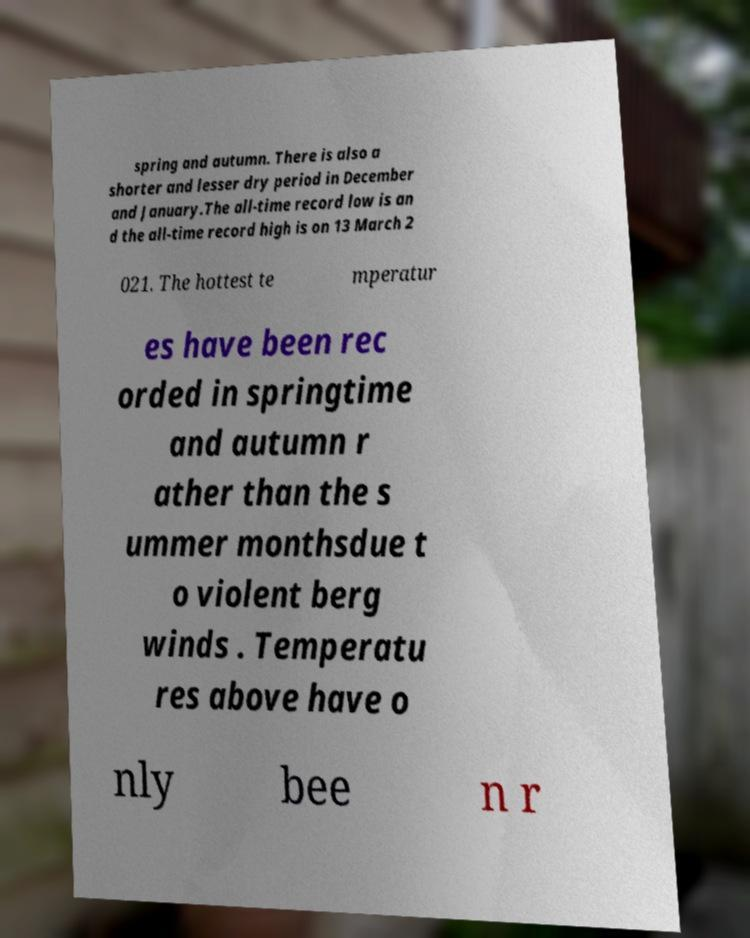What messages or text are displayed in this image? I need them in a readable, typed format. spring and autumn. There is also a shorter and lesser dry period in December and January.The all-time record low is an d the all-time record high is on 13 March 2 021. The hottest te mperatur es have been rec orded in springtime and autumn r ather than the s ummer monthsdue t o violent berg winds . Temperatu res above have o nly bee n r 